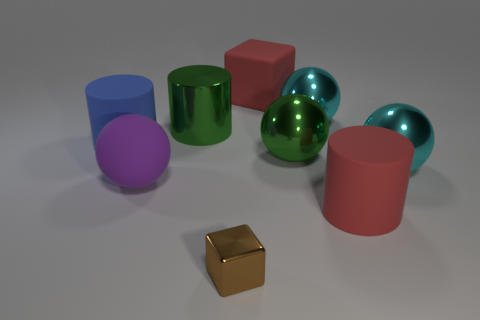The big metal thing that is the same color as the large metal cylinder is what shape?
Make the answer very short. Sphere. What size is the metallic ball that is the same color as the metal cylinder?
Keep it short and to the point. Large. Are there fewer small green matte cylinders than large purple rubber balls?
Your answer should be compact. Yes. What is the material of the blue cylinder that is the same size as the purple thing?
Keep it short and to the point. Rubber. There is a cube behind the brown metallic cube; does it have the same size as the cyan metal object right of the big red cylinder?
Your answer should be very brief. Yes. Is there a large green sphere made of the same material as the large purple thing?
Ensure brevity in your answer.  No. What number of objects are either large matte objects in front of the big blue rubber cylinder or small gray metal cylinders?
Ensure brevity in your answer.  2. Does the large red object behind the red matte cylinder have the same material as the big purple thing?
Your answer should be compact. Yes. There is a large red object that is on the right side of the big red block; what number of purple matte objects are in front of it?
Your response must be concise. 0. There is a large object that is the same shape as the small metallic object; what material is it?
Give a very brief answer. Rubber. 